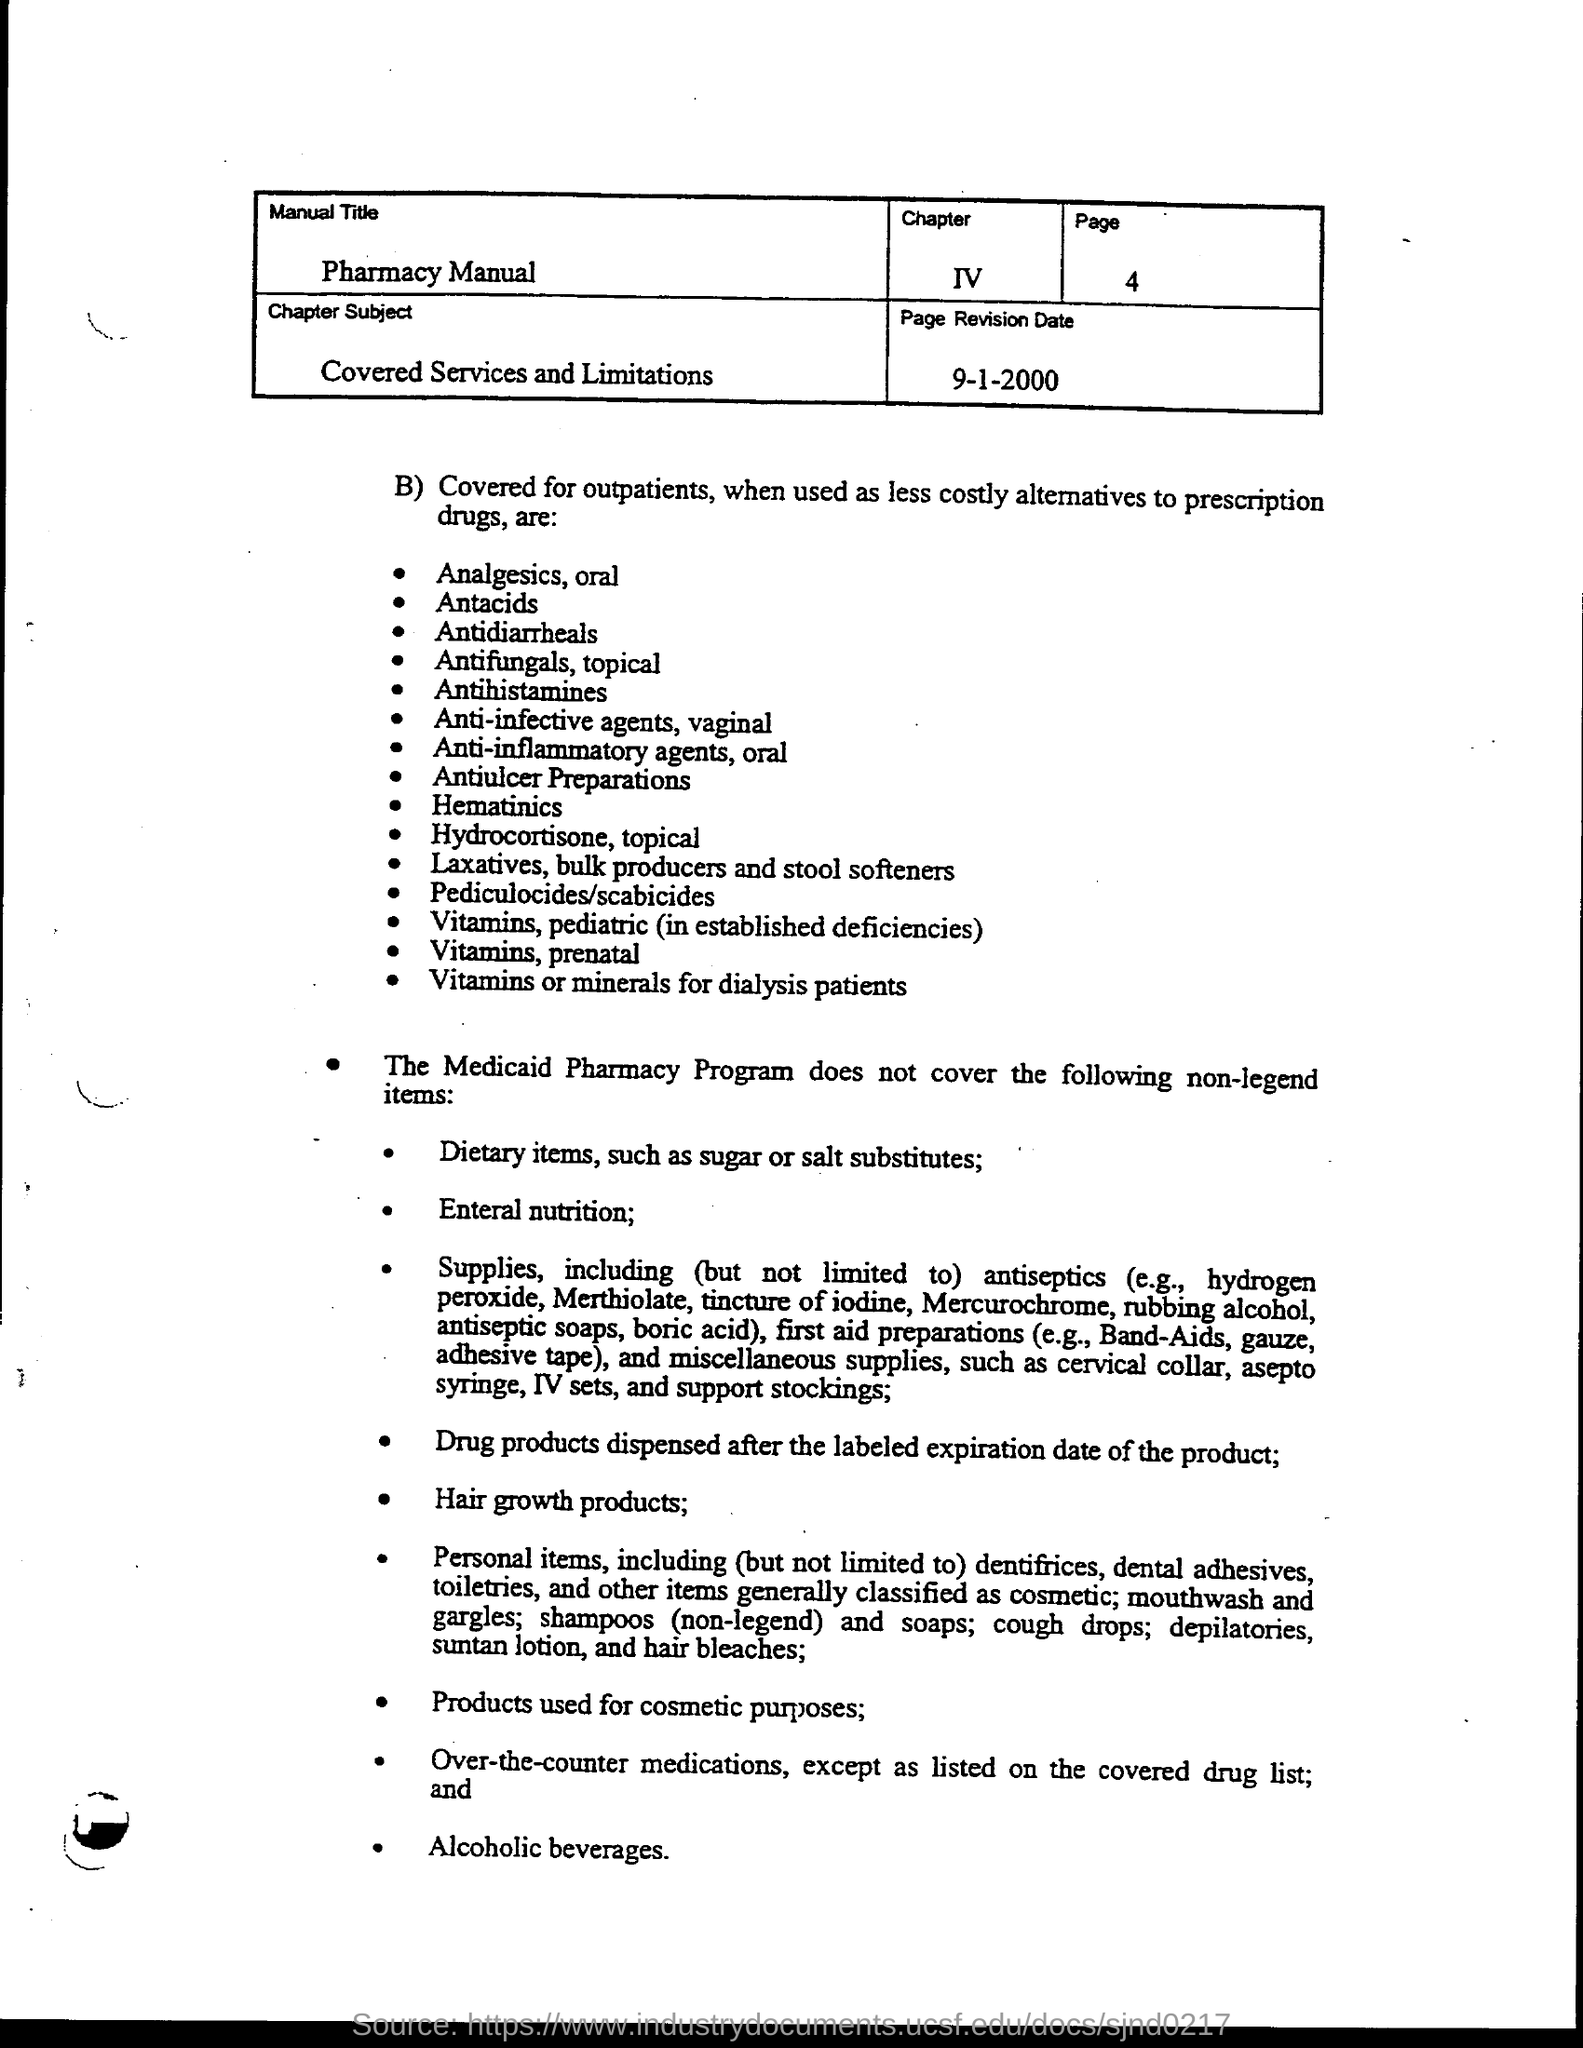Identify some key points in this picture. The chapter number is IV.. Please provide the page number, starting from page 4. The page revision date is September 1, 2000. The Pharmacy Manual is the official guide for all matters related to the operation and management of the pharmacy. The chapter is about the subject of "Covered Services and Limitations. 